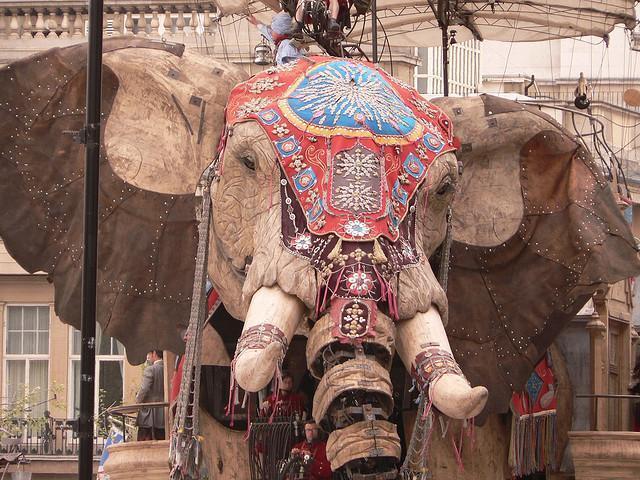How many umbrellas are in the picture?
Give a very brief answer. 1. How many beach chairs are in this picture?
Give a very brief answer. 0. 